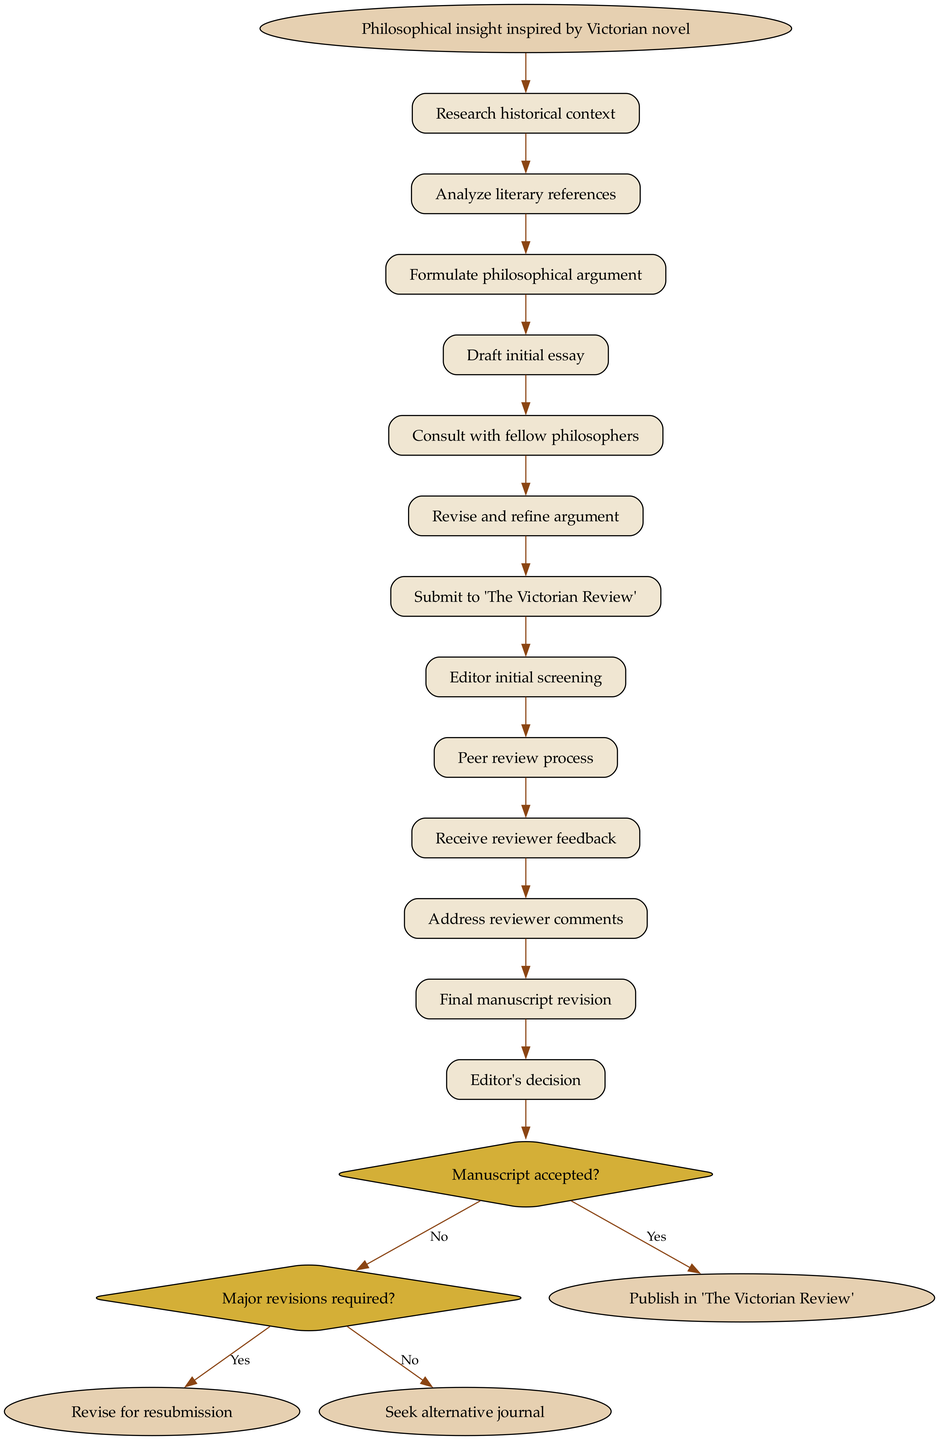What is the first node in the diagram? The first node is labeled "Philosophical insight inspired by Victorian novel," indicating the starting point of the journey of a philosophical idea.
Answer: Philosophical insight inspired by Victorian novel How many activities are listed in the diagram? There are 13 activities represented as nodes in the diagram from start to the first decision node, indicating the steps involved in developing the philosophical idea.
Answer: 13 What is the last node that can be reached if the manuscript is accepted? The end node reached if the manuscript is accepted is "Publish in 'The Victorian Review'," representing the successful publication outcome.
Answer: Publish in 'The Victorian Review' What happens if major revisions are required? If major revisions are required, the next step is to "Revise for resubmission," indicating that the manuscript needs to be improved before resubmitting it.
Answer: Revise for resubmission What is the relationship between "Draft initial essay" and "Consult with fellow philosophers"? "Consult with fellow philosophers" follows "Draft initial essay," indicating that consulting occurs after the initial drafting of the essay.
Answer: Consulting occurs after drafting What decision follows the "Editor initial screening" activity? The decision that follows is "Manuscript accepted?" which determines the next steps based on the acceptance of the manuscript.
Answer: Manuscript accepted? What is the connection between "Receive reviewer feedback" and "Address reviewer comments"? "Address reviewer comments" occurs after "Receive reviewer feedback," signifying a process where feedback is considered and incorporates changes to the manuscript.
Answer: Address reviewer comments Which node requires an analysis of literary references? The node that requires an analysis of literary references is "Analyze literary references," which is part of the research activities.
Answer: Analyze literary references What will be the next step if the editor’s decision is "No"? If the editor's decision is "No," the next step would be "Seek alternative journal," revealing the action taken when a manuscript is not accepted.
Answer: Seek alternative journal 